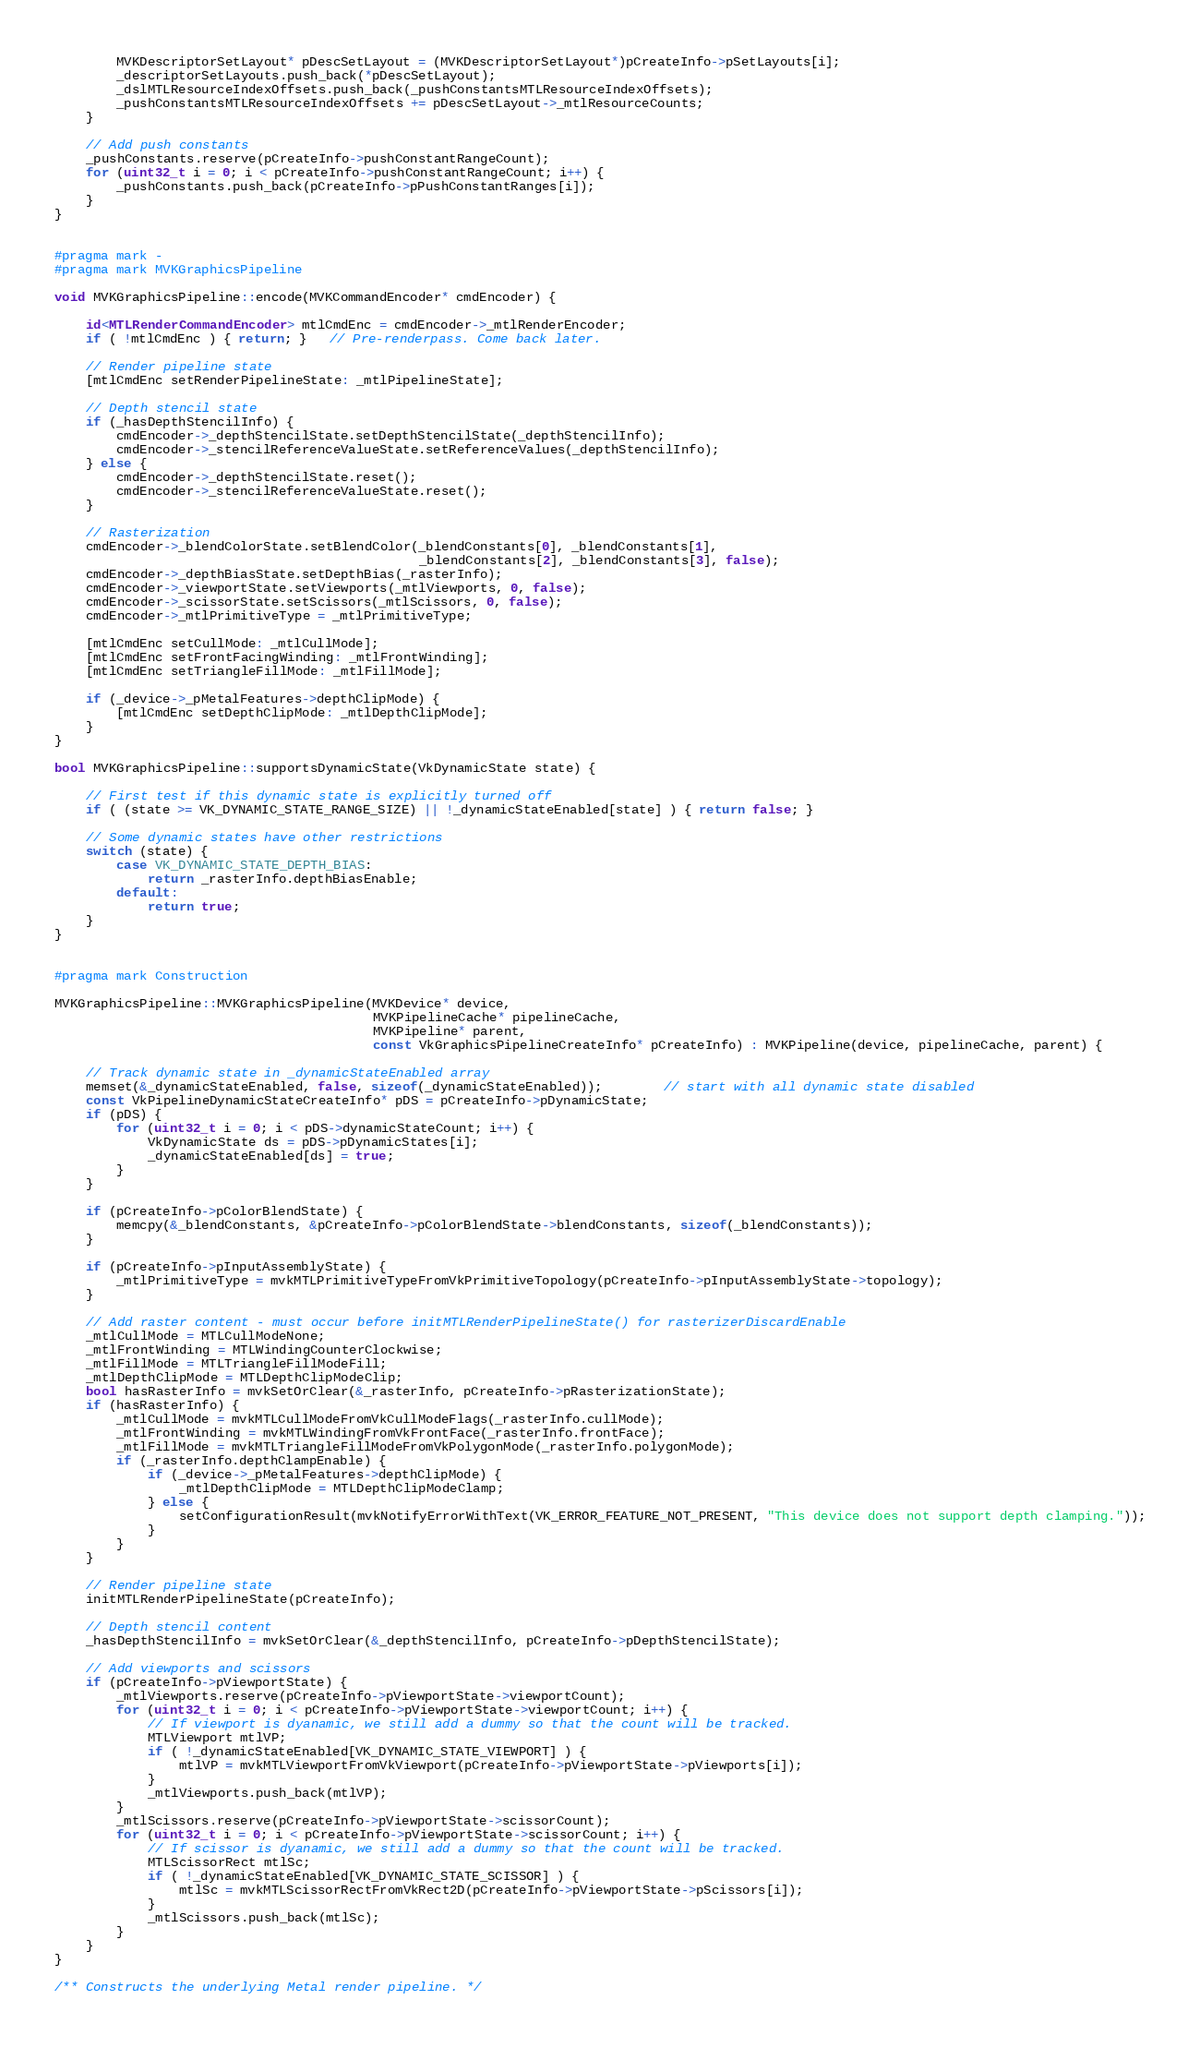Convert code to text. <code><loc_0><loc_0><loc_500><loc_500><_ObjectiveC_>		MVKDescriptorSetLayout* pDescSetLayout = (MVKDescriptorSetLayout*)pCreateInfo->pSetLayouts[i];
		_descriptorSetLayouts.push_back(*pDescSetLayout);
		_dslMTLResourceIndexOffsets.push_back(_pushConstantsMTLResourceIndexOffsets);
		_pushConstantsMTLResourceIndexOffsets += pDescSetLayout->_mtlResourceCounts;
	}

	// Add push constants
	_pushConstants.reserve(pCreateInfo->pushConstantRangeCount);
	for (uint32_t i = 0; i < pCreateInfo->pushConstantRangeCount; i++) {
		_pushConstants.push_back(pCreateInfo->pPushConstantRanges[i]);
	}
}


#pragma mark -
#pragma mark MVKGraphicsPipeline

void MVKGraphicsPipeline::encode(MVKCommandEncoder* cmdEncoder) {

	id<MTLRenderCommandEncoder> mtlCmdEnc = cmdEncoder->_mtlRenderEncoder;
    if ( !mtlCmdEnc ) { return; }   // Pre-renderpass. Come back later.

	// Render pipeline state
	[mtlCmdEnc setRenderPipelineState: _mtlPipelineState];

	// Depth stencil state
	if (_hasDepthStencilInfo) {
        cmdEncoder->_depthStencilState.setDepthStencilState(_depthStencilInfo);
        cmdEncoder->_stencilReferenceValueState.setReferenceValues(_depthStencilInfo);
    } else {
        cmdEncoder->_depthStencilState.reset();
        cmdEncoder->_stencilReferenceValueState.reset();
    }

	// Rasterization
    cmdEncoder->_blendColorState.setBlendColor(_blendConstants[0], _blendConstants[1],
                                               _blendConstants[2], _blendConstants[3], false);
    cmdEncoder->_depthBiasState.setDepthBias(_rasterInfo);
    cmdEncoder->_viewportState.setViewports(_mtlViewports, 0, false);
    cmdEncoder->_scissorState.setScissors(_mtlScissors, 0, false);
    cmdEncoder->_mtlPrimitiveType = _mtlPrimitiveType;

    [mtlCmdEnc setCullMode: _mtlCullMode];
    [mtlCmdEnc setFrontFacingWinding: _mtlFrontWinding];
    [mtlCmdEnc setTriangleFillMode: _mtlFillMode];

    if (_device->_pMetalFeatures->depthClipMode) {
        [mtlCmdEnc setDepthClipMode: _mtlDepthClipMode];
    }
}

bool MVKGraphicsPipeline::supportsDynamicState(VkDynamicState state) {

    // First test if this dynamic state is explicitly turned off
    if ( (state >= VK_DYNAMIC_STATE_RANGE_SIZE) || !_dynamicStateEnabled[state] ) { return false; }

    // Some dynamic states have other restrictions
    switch (state) {
        case VK_DYNAMIC_STATE_DEPTH_BIAS:
            return _rasterInfo.depthBiasEnable;
        default:
            return true;
    }
}


#pragma mark Construction

MVKGraphicsPipeline::MVKGraphicsPipeline(MVKDevice* device,
										 MVKPipelineCache* pipelineCache,
										 MVKPipeline* parent,
										 const VkGraphicsPipelineCreateInfo* pCreateInfo) : MVKPipeline(device, pipelineCache, parent) {

    // Track dynamic state in _dynamicStateEnabled array
	memset(&_dynamicStateEnabled, false, sizeof(_dynamicStateEnabled));		// start with all dynamic state disabled
	const VkPipelineDynamicStateCreateInfo* pDS = pCreateInfo->pDynamicState;
	if (pDS) {
		for (uint32_t i = 0; i < pDS->dynamicStateCount; i++) {
			VkDynamicState ds = pDS->pDynamicStates[i];
			_dynamicStateEnabled[ds] = true;
		}
	}

    if (pCreateInfo->pColorBlendState) {
        memcpy(&_blendConstants, &pCreateInfo->pColorBlendState->blendConstants, sizeof(_blendConstants));
    }

    if (pCreateInfo->pInputAssemblyState) {
        _mtlPrimitiveType = mvkMTLPrimitiveTypeFromVkPrimitiveTopology(pCreateInfo->pInputAssemblyState->topology);
    }

	// Add raster content - must occur before initMTLRenderPipelineState() for rasterizerDiscardEnable
	_mtlCullMode = MTLCullModeNone;
	_mtlFrontWinding = MTLWindingCounterClockwise;
	_mtlFillMode = MTLTriangleFillModeFill;
    _mtlDepthClipMode = MTLDepthClipModeClip;
	bool hasRasterInfo = mvkSetOrClear(&_rasterInfo, pCreateInfo->pRasterizationState);
	if (hasRasterInfo) {
		_mtlCullMode = mvkMTLCullModeFromVkCullModeFlags(_rasterInfo.cullMode);
		_mtlFrontWinding = mvkMTLWindingFromVkFrontFace(_rasterInfo.frontFace);
		_mtlFillMode = mvkMTLTriangleFillModeFromVkPolygonMode(_rasterInfo.polygonMode);
        if (_rasterInfo.depthClampEnable) {
            if (_device->_pMetalFeatures->depthClipMode) {
                _mtlDepthClipMode = MTLDepthClipModeClamp;
            } else {
                setConfigurationResult(mvkNotifyErrorWithText(VK_ERROR_FEATURE_NOT_PRESENT, "This device does not support depth clamping."));
            }
        }
	}

	// Render pipeline state
	initMTLRenderPipelineState(pCreateInfo);

	// Depth stencil content
	_hasDepthStencilInfo = mvkSetOrClear(&_depthStencilInfo, pCreateInfo->pDepthStencilState);

	// Add viewports and scissors
	if (pCreateInfo->pViewportState) {
		_mtlViewports.reserve(pCreateInfo->pViewportState->viewportCount);
		for (uint32_t i = 0; i < pCreateInfo->pViewportState->viewportCount; i++) {
			// If viewport is dyanamic, we still add a dummy so that the count will be tracked.
			MTLViewport mtlVP;
			if ( !_dynamicStateEnabled[VK_DYNAMIC_STATE_VIEWPORT] ) {
				mtlVP = mvkMTLViewportFromVkViewport(pCreateInfo->pViewportState->pViewports[i]);
			}
			_mtlViewports.push_back(mtlVP);
		}
		_mtlScissors.reserve(pCreateInfo->pViewportState->scissorCount);
		for (uint32_t i = 0; i < pCreateInfo->pViewportState->scissorCount; i++) {
			// If scissor is dyanamic, we still add a dummy so that the count will be tracked.
			MTLScissorRect mtlSc;
			if ( !_dynamicStateEnabled[VK_DYNAMIC_STATE_SCISSOR] ) {
				mtlSc = mvkMTLScissorRectFromVkRect2D(pCreateInfo->pViewportState->pScissors[i]);
			}
			_mtlScissors.push_back(mtlSc);
		}
	}
}

/** Constructs the underlying Metal render pipeline. */</code> 